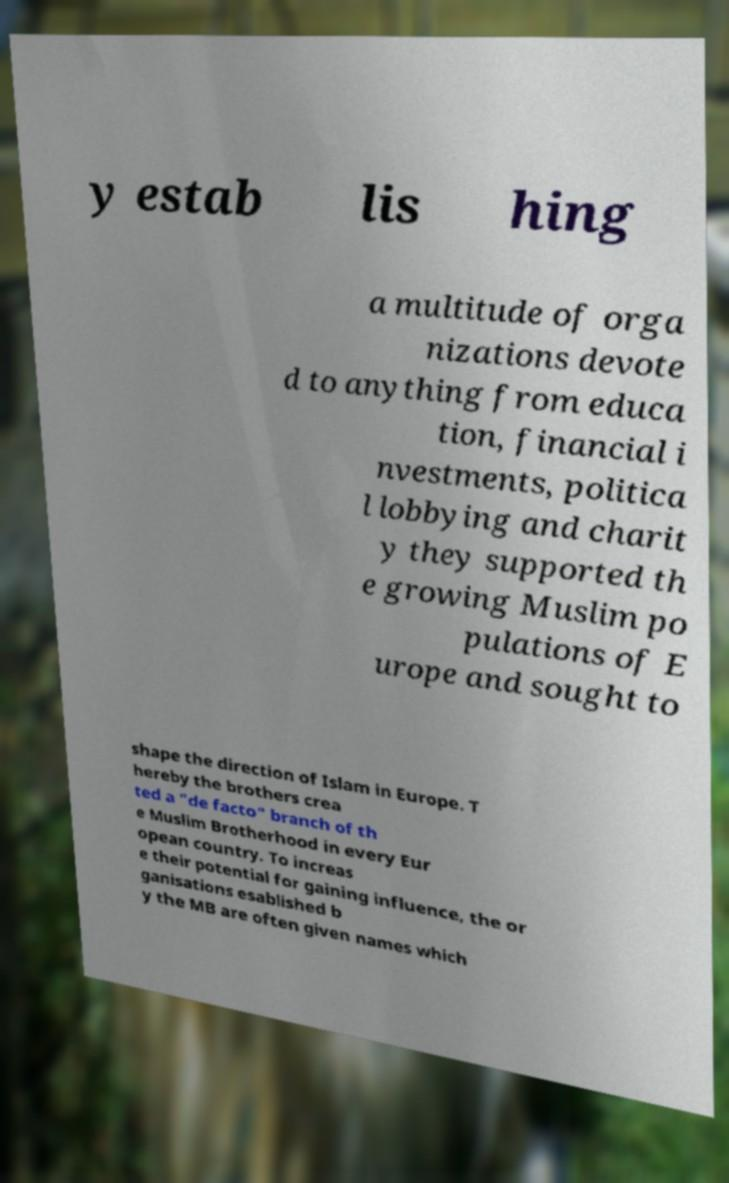Please identify and transcribe the text found in this image. y estab lis hing a multitude of orga nizations devote d to anything from educa tion, financial i nvestments, politica l lobbying and charit y they supported th e growing Muslim po pulations of E urope and sought to shape the direction of Islam in Europe. T hereby the brothers crea ted a "de facto" branch of th e Muslim Brotherhood in every Eur opean country. To increas e their potential for gaining influence, the or ganisations esablished b y the MB are often given names which 